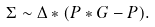Convert formula to latex. <formula><loc_0><loc_0><loc_500><loc_500>\Sigma \sim \Delta * ( P * G - P ) .</formula> 